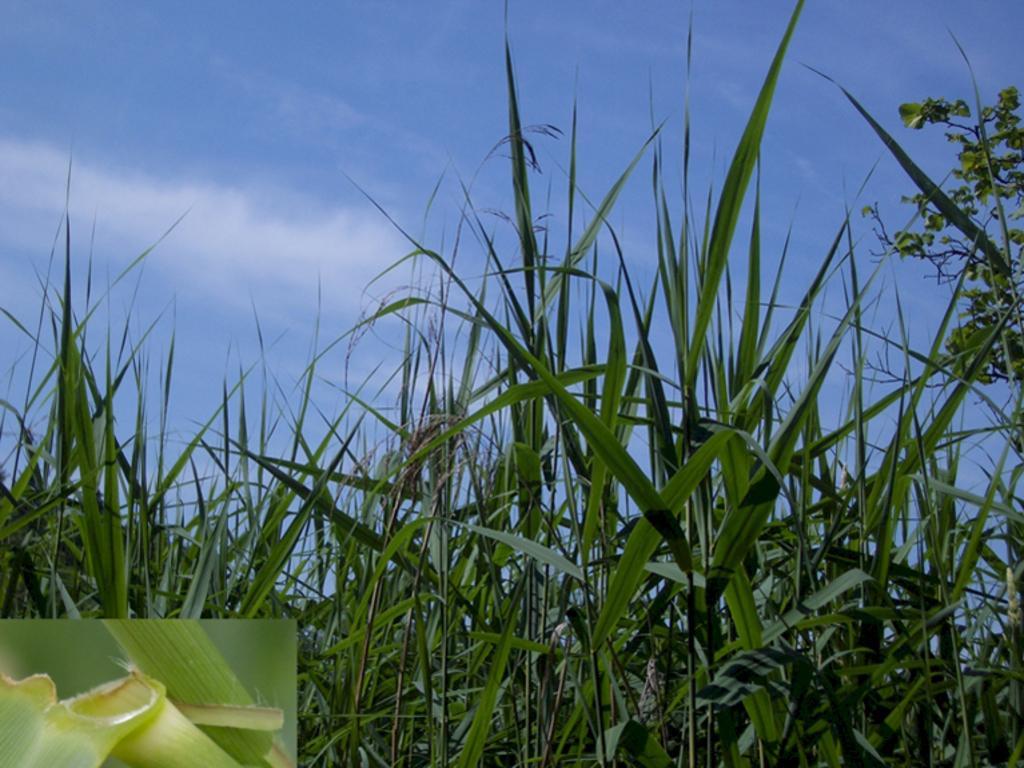Describe this image in one or two sentences. In this image I can see few green plants. The sky is in blue and white color. 